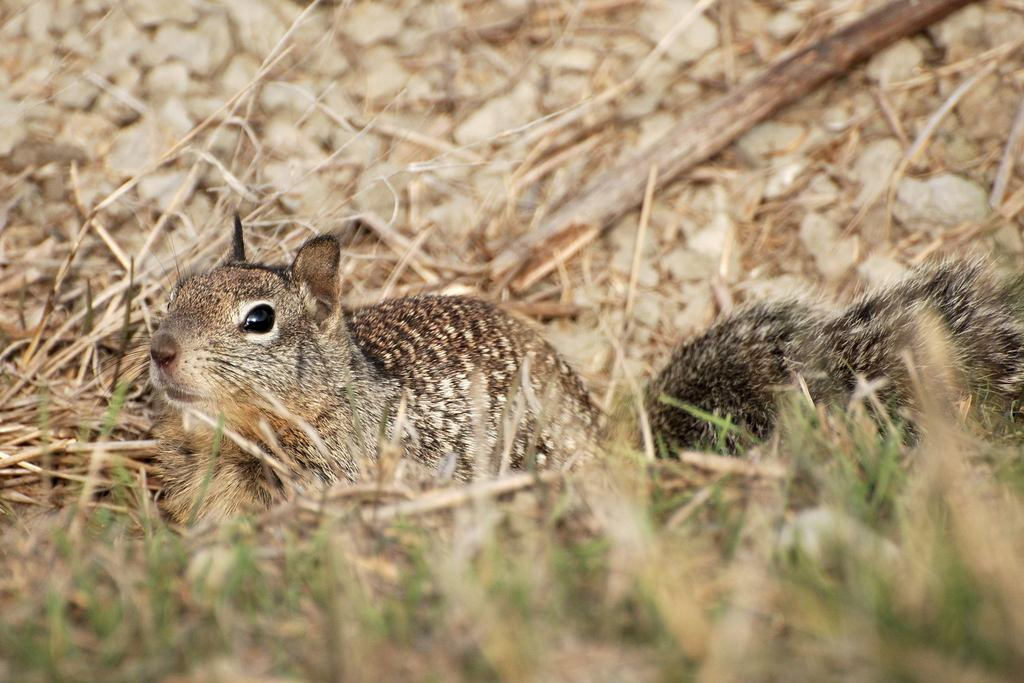What type of animal is in the image? There is a small animal in the image. Where is the animal located in the image? The animal is sitting on the grass ground. What is the animal doing in the image? The animal is looking at someone. What type of range can be seen in the background of the image? There is no range visible in the image; it only features a small animal sitting on the grass ground and looking at someone. 